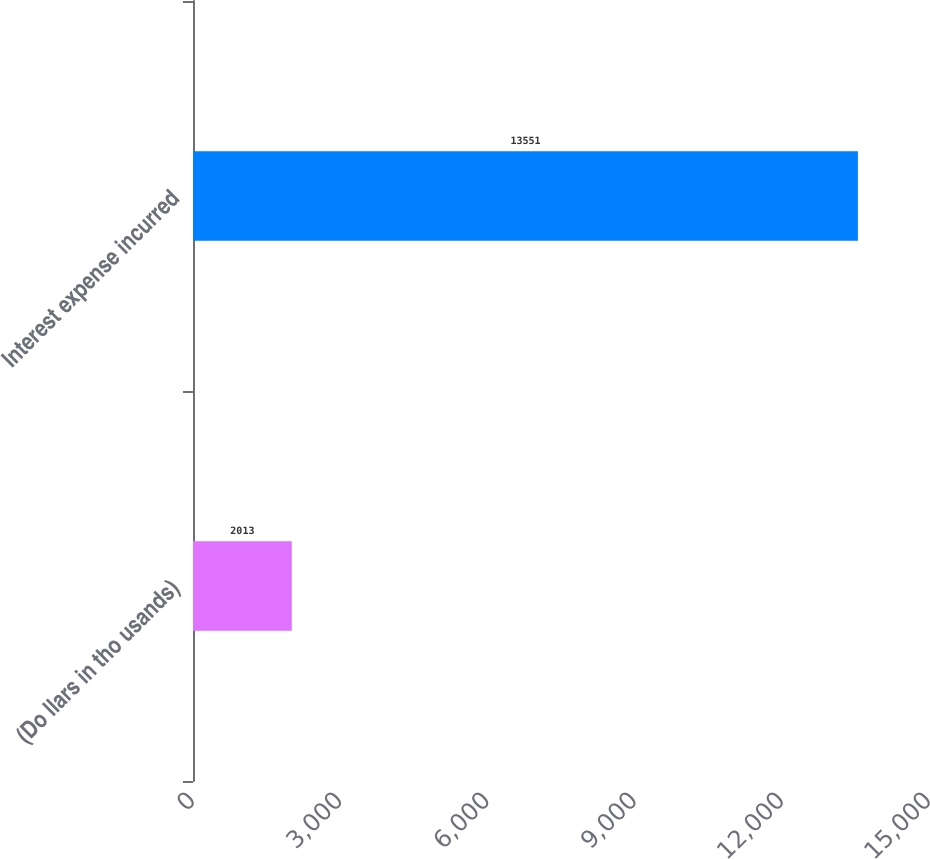<chart> <loc_0><loc_0><loc_500><loc_500><bar_chart><fcel>(Do llars in tho usands)<fcel>Interest expense incurred<nl><fcel>2013<fcel>13551<nl></chart> 